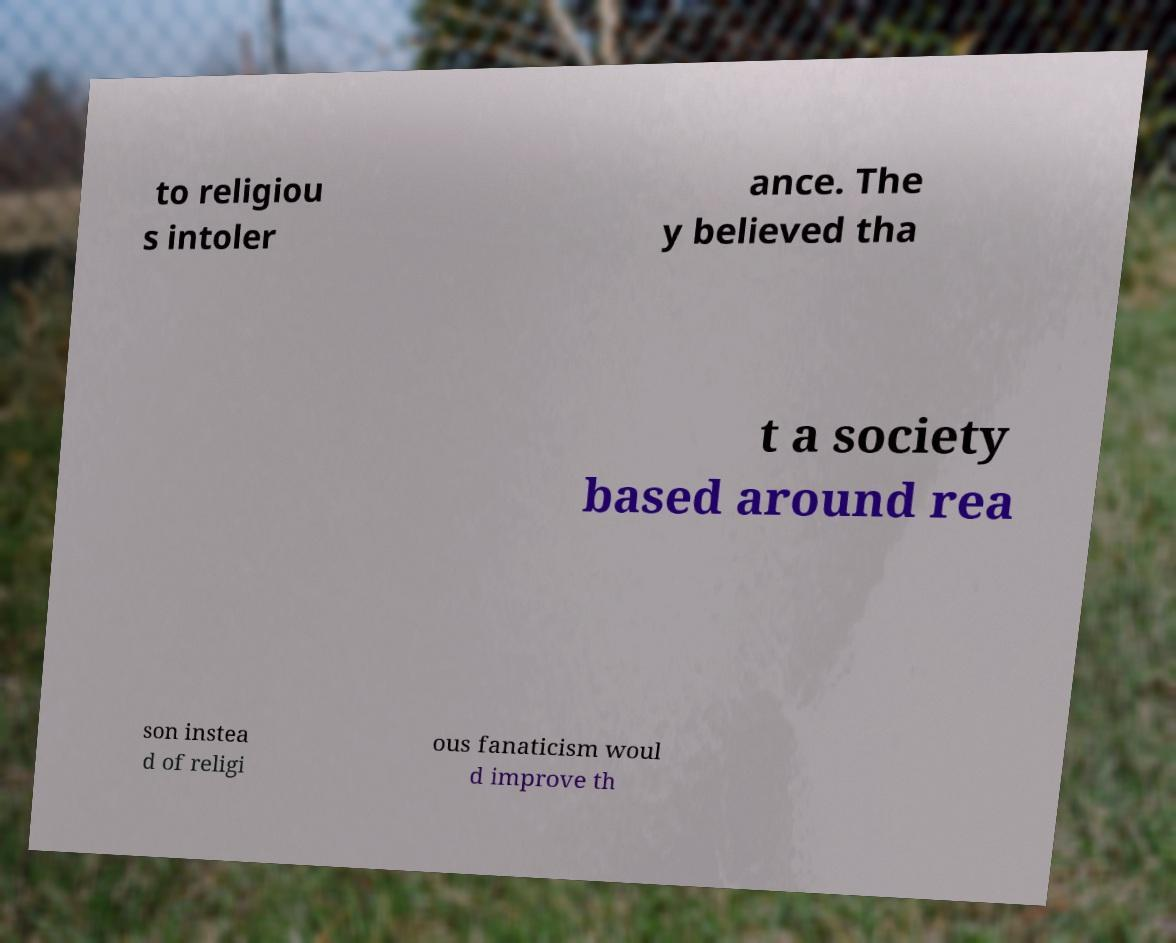Could you extract and type out the text from this image? to religiou s intoler ance. The y believed tha t a society based around rea son instea d of religi ous fanaticism woul d improve th 